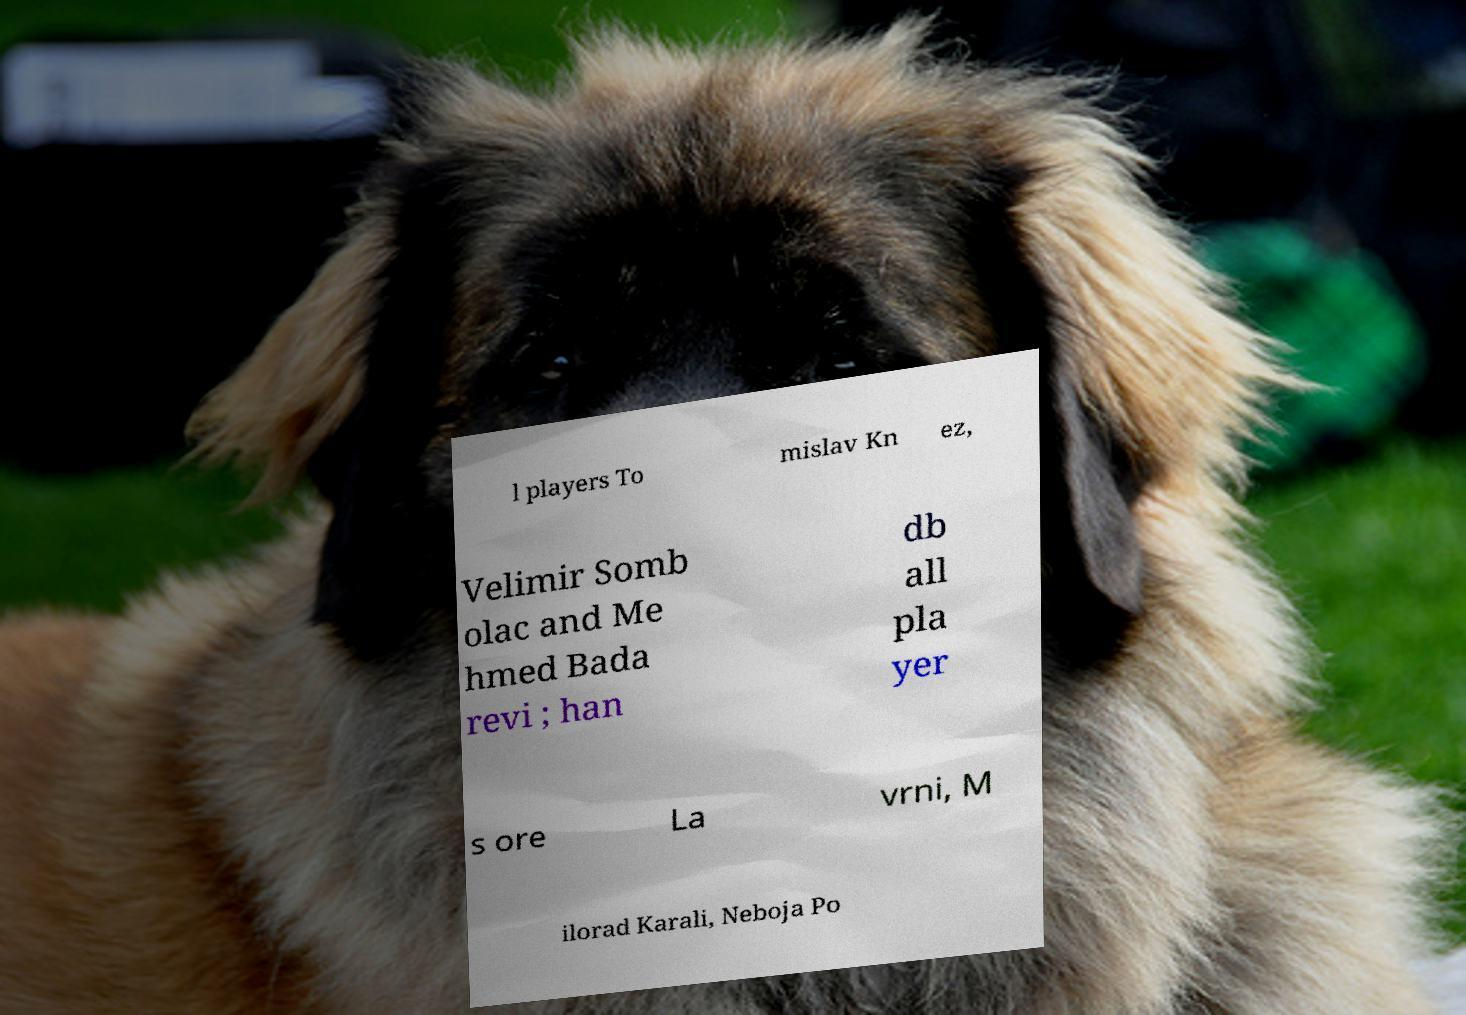Can you read and provide the text displayed in the image?This photo seems to have some interesting text. Can you extract and type it out for me? l players To mislav Kn ez, Velimir Somb olac and Me hmed Bada revi ; han db all pla yer s ore La vrni, M ilorad Karali, Neboja Po 